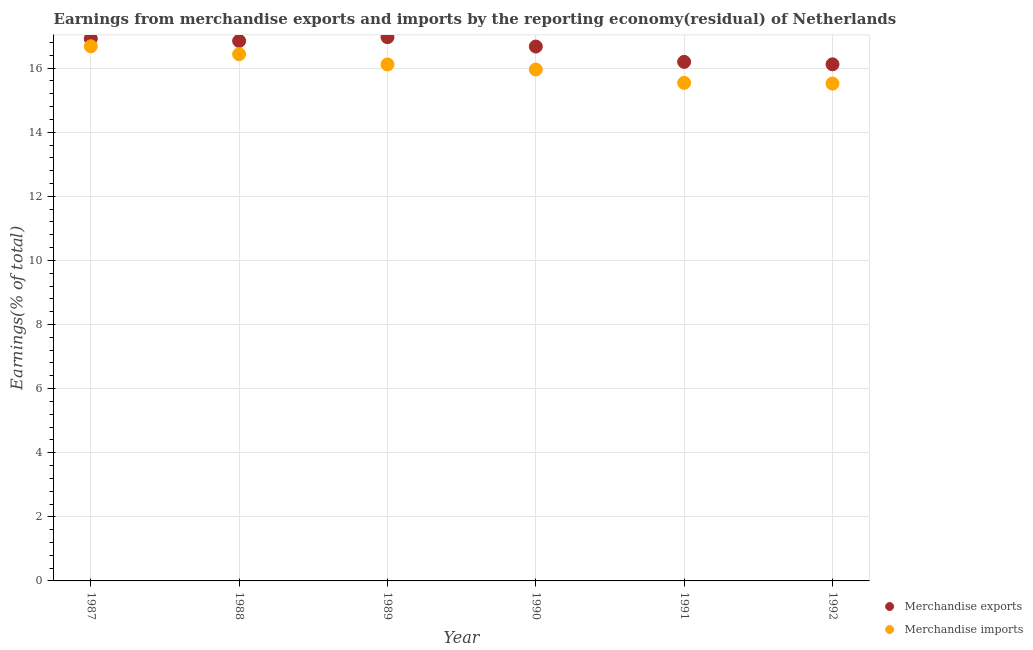How many different coloured dotlines are there?
Give a very brief answer. 2. What is the earnings from merchandise exports in 1989?
Provide a short and direct response. 16.97. Across all years, what is the maximum earnings from merchandise imports?
Make the answer very short. 16.68. Across all years, what is the minimum earnings from merchandise exports?
Your response must be concise. 16.12. In which year was the earnings from merchandise imports maximum?
Provide a short and direct response. 1987. In which year was the earnings from merchandise imports minimum?
Ensure brevity in your answer.  1992. What is the total earnings from merchandise imports in the graph?
Make the answer very short. 96.25. What is the difference between the earnings from merchandise exports in 1988 and that in 1992?
Your response must be concise. 0.73. What is the difference between the earnings from merchandise imports in 1992 and the earnings from merchandise exports in 1991?
Give a very brief answer. -0.68. What is the average earnings from merchandise imports per year?
Ensure brevity in your answer.  16.04. In the year 1990, what is the difference between the earnings from merchandise exports and earnings from merchandise imports?
Ensure brevity in your answer.  0.72. In how many years, is the earnings from merchandise exports greater than 4 %?
Your response must be concise. 6. What is the ratio of the earnings from merchandise exports in 1987 to that in 1992?
Keep it short and to the point. 1.05. Is the earnings from merchandise imports in 1987 less than that in 1990?
Your answer should be very brief. No. What is the difference between the highest and the second highest earnings from merchandise imports?
Provide a succinct answer. 0.25. What is the difference between the highest and the lowest earnings from merchandise exports?
Give a very brief answer. 0.85. How many years are there in the graph?
Ensure brevity in your answer.  6. Does the graph contain grids?
Keep it short and to the point. Yes. What is the title of the graph?
Your response must be concise. Earnings from merchandise exports and imports by the reporting economy(residual) of Netherlands. What is the label or title of the X-axis?
Your answer should be very brief. Year. What is the label or title of the Y-axis?
Give a very brief answer. Earnings(% of total). What is the Earnings(% of total) of Merchandise exports in 1987?
Your answer should be very brief. 16.92. What is the Earnings(% of total) in Merchandise imports in 1987?
Your answer should be compact. 16.68. What is the Earnings(% of total) in Merchandise exports in 1988?
Make the answer very short. 16.85. What is the Earnings(% of total) in Merchandise imports in 1988?
Keep it short and to the point. 16.44. What is the Earnings(% of total) in Merchandise exports in 1989?
Ensure brevity in your answer.  16.97. What is the Earnings(% of total) of Merchandise imports in 1989?
Offer a terse response. 16.11. What is the Earnings(% of total) of Merchandise exports in 1990?
Your answer should be compact. 16.67. What is the Earnings(% of total) in Merchandise imports in 1990?
Provide a succinct answer. 15.96. What is the Earnings(% of total) in Merchandise exports in 1991?
Offer a very short reply. 16.2. What is the Earnings(% of total) in Merchandise imports in 1991?
Make the answer very short. 15.54. What is the Earnings(% of total) of Merchandise exports in 1992?
Provide a succinct answer. 16.12. What is the Earnings(% of total) of Merchandise imports in 1992?
Give a very brief answer. 15.52. Across all years, what is the maximum Earnings(% of total) in Merchandise exports?
Offer a terse response. 16.97. Across all years, what is the maximum Earnings(% of total) of Merchandise imports?
Keep it short and to the point. 16.68. Across all years, what is the minimum Earnings(% of total) of Merchandise exports?
Ensure brevity in your answer.  16.12. Across all years, what is the minimum Earnings(% of total) in Merchandise imports?
Offer a very short reply. 15.52. What is the total Earnings(% of total) of Merchandise exports in the graph?
Offer a very short reply. 99.72. What is the total Earnings(% of total) of Merchandise imports in the graph?
Provide a succinct answer. 96.25. What is the difference between the Earnings(% of total) of Merchandise exports in 1987 and that in 1988?
Keep it short and to the point. 0.07. What is the difference between the Earnings(% of total) of Merchandise imports in 1987 and that in 1988?
Your response must be concise. 0.25. What is the difference between the Earnings(% of total) in Merchandise exports in 1987 and that in 1989?
Your response must be concise. -0.05. What is the difference between the Earnings(% of total) of Merchandise imports in 1987 and that in 1989?
Provide a succinct answer. 0.57. What is the difference between the Earnings(% of total) of Merchandise exports in 1987 and that in 1990?
Ensure brevity in your answer.  0.25. What is the difference between the Earnings(% of total) in Merchandise imports in 1987 and that in 1990?
Your answer should be compact. 0.72. What is the difference between the Earnings(% of total) of Merchandise exports in 1987 and that in 1991?
Offer a terse response. 0.72. What is the difference between the Earnings(% of total) in Merchandise imports in 1987 and that in 1991?
Offer a very short reply. 1.14. What is the difference between the Earnings(% of total) of Merchandise exports in 1987 and that in 1992?
Ensure brevity in your answer.  0.8. What is the difference between the Earnings(% of total) of Merchandise imports in 1987 and that in 1992?
Your answer should be compact. 1.16. What is the difference between the Earnings(% of total) in Merchandise exports in 1988 and that in 1989?
Offer a terse response. -0.12. What is the difference between the Earnings(% of total) of Merchandise imports in 1988 and that in 1989?
Keep it short and to the point. 0.32. What is the difference between the Earnings(% of total) of Merchandise exports in 1988 and that in 1990?
Make the answer very short. 0.17. What is the difference between the Earnings(% of total) in Merchandise imports in 1988 and that in 1990?
Your answer should be compact. 0.48. What is the difference between the Earnings(% of total) in Merchandise exports in 1988 and that in 1991?
Your response must be concise. 0.65. What is the difference between the Earnings(% of total) of Merchandise imports in 1988 and that in 1991?
Ensure brevity in your answer.  0.89. What is the difference between the Earnings(% of total) of Merchandise exports in 1988 and that in 1992?
Keep it short and to the point. 0.73. What is the difference between the Earnings(% of total) in Merchandise imports in 1988 and that in 1992?
Your response must be concise. 0.92. What is the difference between the Earnings(% of total) in Merchandise exports in 1989 and that in 1990?
Your answer should be compact. 0.29. What is the difference between the Earnings(% of total) of Merchandise imports in 1989 and that in 1990?
Your response must be concise. 0.16. What is the difference between the Earnings(% of total) in Merchandise exports in 1989 and that in 1991?
Provide a succinct answer. 0.77. What is the difference between the Earnings(% of total) in Merchandise imports in 1989 and that in 1991?
Provide a succinct answer. 0.57. What is the difference between the Earnings(% of total) in Merchandise exports in 1989 and that in 1992?
Give a very brief answer. 0.85. What is the difference between the Earnings(% of total) of Merchandise imports in 1989 and that in 1992?
Offer a terse response. 0.6. What is the difference between the Earnings(% of total) of Merchandise exports in 1990 and that in 1991?
Keep it short and to the point. 0.48. What is the difference between the Earnings(% of total) of Merchandise imports in 1990 and that in 1991?
Keep it short and to the point. 0.42. What is the difference between the Earnings(% of total) of Merchandise exports in 1990 and that in 1992?
Provide a succinct answer. 0.55. What is the difference between the Earnings(% of total) of Merchandise imports in 1990 and that in 1992?
Give a very brief answer. 0.44. What is the difference between the Earnings(% of total) in Merchandise exports in 1991 and that in 1992?
Provide a succinct answer. 0.08. What is the difference between the Earnings(% of total) of Merchandise imports in 1991 and that in 1992?
Provide a short and direct response. 0.02. What is the difference between the Earnings(% of total) in Merchandise exports in 1987 and the Earnings(% of total) in Merchandise imports in 1988?
Your response must be concise. 0.48. What is the difference between the Earnings(% of total) in Merchandise exports in 1987 and the Earnings(% of total) in Merchandise imports in 1989?
Provide a succinct answer. 0.81. What is the difference between the Earnings(% of total) of Merchandise exports in 1987 and the Earnings(% of total) of Merchandise imports in 1990?
Your response must be concise. 0.96. What is the difference between the Earnings(% of total) of Merchandise exports in 1987 and the Earnings(% of total) of Merchandise imports in 1991?
Make the answer very short. 1.38. What is the difference between the Earnings(% of total) of Merchandise exports in 1987 and the Earnings(% of total) of Merchandise imports in 1992?
Provide a short and direct response. 1.4. What is the difference between the Earnings(% of total) in Merchandise exports in 1988 and the Earnings(% of total) in Merchandise imports in 1989?
Make the answer very short. 0.73. What is the difference between the Earnings(% of total) of Merchandise exports in 1988 and the Earnings(% of total) of Merchandise imports in 1990?
Keep it short and to the point. 0.89. What is the difference between the Earnings(% of total) in Merchandise exports in 1988 and the Earnings(% of total) in Merchandise imports in 1991?
Give a very brief answer. 1.31. What is the difference between the Earnings(% of total) in Merchandise exports in 1988 and the Earnings(% of total) in Merchandise imports in 1992?
Make the answer very short. 1.33. What is the difference between the Earnings(% of total) in Merchandise exports in 1989 and the Earnings(% of total) in Merchandise imports in 1990?
Provide a succinct answer. 1.01. What is the difference between the Earnings(% of total) in Merchandise exports in 1989 and the Earnings(% of total) in Merchandise imports in 1991?
Make the answer very short. 1.42. What is the difference between the Earnings(% of total) in Merchandise exports in 1989 and the Earnings(% of total) in Merchandise imports in 1992?
Offer a terse response. 1.45. What is the difference between the Earnings(% of total) of Merchandise exports in 1990 and the Earnings(% of total) of Merchandise imports in 1991?
Make the answer very short. 1.13. What is the difference between the Earnings(% of total) of Merchandise exports in 1990 and the Earnings(% of total) of Merchandise imports in 1992?
Ensure brevity in your answer.  1.16. What is the difference between the Earnings(% of total) of Merchandise exports in 1991 and the Earnings(% of total) of Merchandise imports in 1992?
Ensure brevity in your answer.  0.68. What is the average Earnings(% of total) of Merchandise exports per year?
Your answer should be very brief. 16.62. What is the average Earnings(% of total) of Merchandise imports per year?
Your answer should be compact. 16.04. In the year 1987, what is the difference between the Earnings(% of total) in Merchandise exports and Earnings(% of total) in Merchandise imports?
Provide a succinct answer. 0.24. In the year 1988, what is the difference between the Earnings(% of total) of Merchandise exports and Earnings(% of total) of Merchandise imports?
Give a very brief answer. 0.41. In the year 1989, what is the difference between the Earnings(% of total) of Merchandise exports and Earnings(% of total) of Merchandise imports?
Your answer should be compact. 0.85. In the year 1990, what is the difference between the Earnings(% of total) in Merchandise exports and Earnings(% of total) in Merchandise imports?
Your answer should be very brief. 0.72. In the year 1991, what is the difference between the Earnings(% of total) in Merchandise exports and Earnings(% of total) in Merchandise imports?
Give a very brief answer. 0.65. In the year 1992, what is the difference between the Earnings(% of total) in Merchandise exports and Earnings(% of total) in Merchandise imports?
Provide a succinct answer. 0.6. What is the ratio of the Earnings(% of total) of Merchandise exports in 1987 to that in 1988?
Give a very brief answer. 1. What is the ratio of the Earnings(% of total) in Merchandise imports in 1987 to that in 1989?
Keep it short and to the point. 1.04. What is the ratio of the Earnings(% of total) of Merchandise exports in 1987 to that in 1990?
Keep it short and to the point. 1.01. What is the ratio of the Earnings(% of total) in Merchandise imports in 1987 to that in 1990?
Offer a terse response. 1.05. What is the ratio of the Earnings(% of total) of Merchandise exports in 1987 to that in 1991?
Make the answer very short. 1.04. What is the ratio of the Earnings(% of total) in Merchandise imports in 1987 to that in 1991?
Your response must be concise. 1.07. What is the ratio of the Earnings(% of total) of Merchandise exports in 1987 to that in 1992?
Provide a short and direct response. 1.05. What is the ratio of the Earnings(% of total) in Merchandise imports in 1987 to that in 1992?
Your answer should be very brief. 1.07. What is the ratio of the Earnings(% of total) in Merchandise exports in 1988 to that in 1989?
Provide a short and direct response. 0.99. What is the ratio of the Earnings(% of total) in Merchandise imports in 1988 to that in 1989?
Ensure brevity in your answer.  1.02. What is the ratio of the Earnings(% of total) of Merchandise exports in 1988 to that in 1990?
Your answer should be compact. 1.01. What is the ratio of the Earnings(% of total) of Merchandise imports in 1988 to that in 1990?
Make the answer very short. 1.03. What is the ratio of the Earnings(% of total) of Merchandise exports in 1988 to that in 1991?
Your response must be concise. 1.04. What is the ratio of the Earnings(% of total) in Merchandise imports in 1988 to that in 1991?
Ensure brevity in your answer.  1.06. What is the ratio of the Earnings(% of total) in Merchandise exports in 1988 to that in 1992?
Provide a short and direct response. 1.05. What is the ratio of the Earnings(% of total) of Merchandise imports in 1988 to that in 1992?
Your response must be concise. 1.06. What is the ratio of the Earnings(% of total) of Merchandise exports in 1989 to that in 1990?
Provide a succinct answer. 1.02. What is the ratio of the Earnings(% of total) of Merchandise imports in 1989 to that in 1990?
Your answer should be compact. 1.01. What is the ratio of the Earnings(% of total) of Merchandise exports in 1989 to that in 1991?
Make the answer very short. 1.05. What is the ratio of the Earnings(% of total) of Merchandise imports in 1989 to that in 1991?
Your answer should be very brief. 1.04. What is the ratio of the Earnings(% of total) in Merchandise exports in 1989 to that in 1992?
Your answer should be compact. 1.05. What is the ratio of the Earnings(% of total) in Merchandise exports in 1990 to that in 1991?
Your answer should be very brief. 1.03. What is the ratio of the Earnings(% of total) in Merchandise imports in 1990 to that in 1991?
Make the answer very short. 1.03. What is the ratio of the Earnings(% of total) of Merchandise exports in 1990 to that in 1992?
Ensure brevity in your answer.  1.03. What is the ratio of the Earnings(% of total) in Merchandise imports in 1990 to that in 1992?
Your answer should be compact. 1.03. What is the ratio of the Earnings(% of total) of Merchandise exports in 1991 to that in 1992?
Give a very brief answer. 1. What is the difference between the highest and the second highest Earnings(% of total) in Merchandise exports?
Your answer should be very brief. 0.05. What is the difference between the highest and the second highest Earnings(% of total) in Merchandise imports?
Provide a short and direct response. 0.25. What is the difference between the highest and the lowest Earnings(% of total) in Merchandise exports?
Your response must be concise. 0.85. What is the difference between the highest and the lowest Earnings(% of total) of Merchandise imports?
Your answer should be compact. 1.16. 